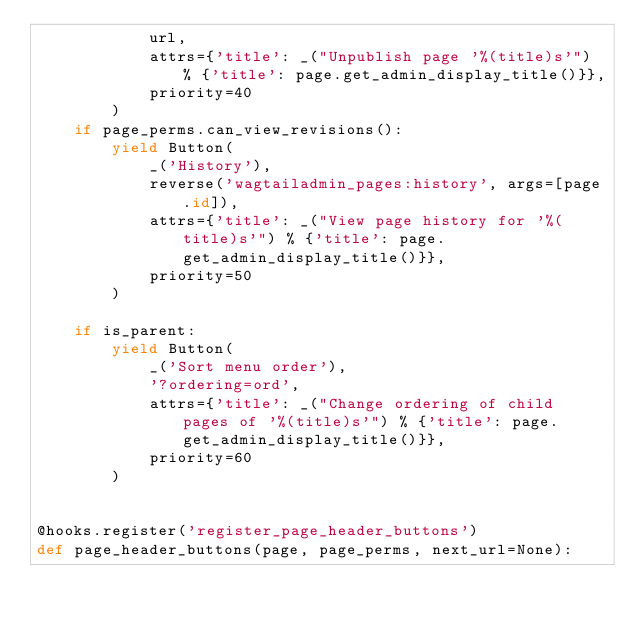Convert code to text. <code><loc_0><loc_0><loc_500><loc_500><_Python_>            url,
            attrs={'title': _("Unpublish page '%(title)s'") % {'title': page.get_admin_display_title()}},
            priority=40
        )
    if page_perms.can_view_revisions():
        yield Button(
            _('History'),
            reverse('wagtailadmin_pages:history', args=[page.id]),
            attrs={'title': _("View page history for '%(title)s'") % {'title': page.get_admin_display_title()}},
            priority=50
        )

    if is_parent:
        yield Button(
            _('Sort menu order'),
            '?ordering=ord',
            attrs={'title': _("Change ordering of child pages of '%(title)s'") % {'title': page.get_admin_display_title()}},
            priority=60
        )


@hooks.register('register_page_header_buttons')
def page_header_buttons(page, page_perms, next_url=None):</code> 